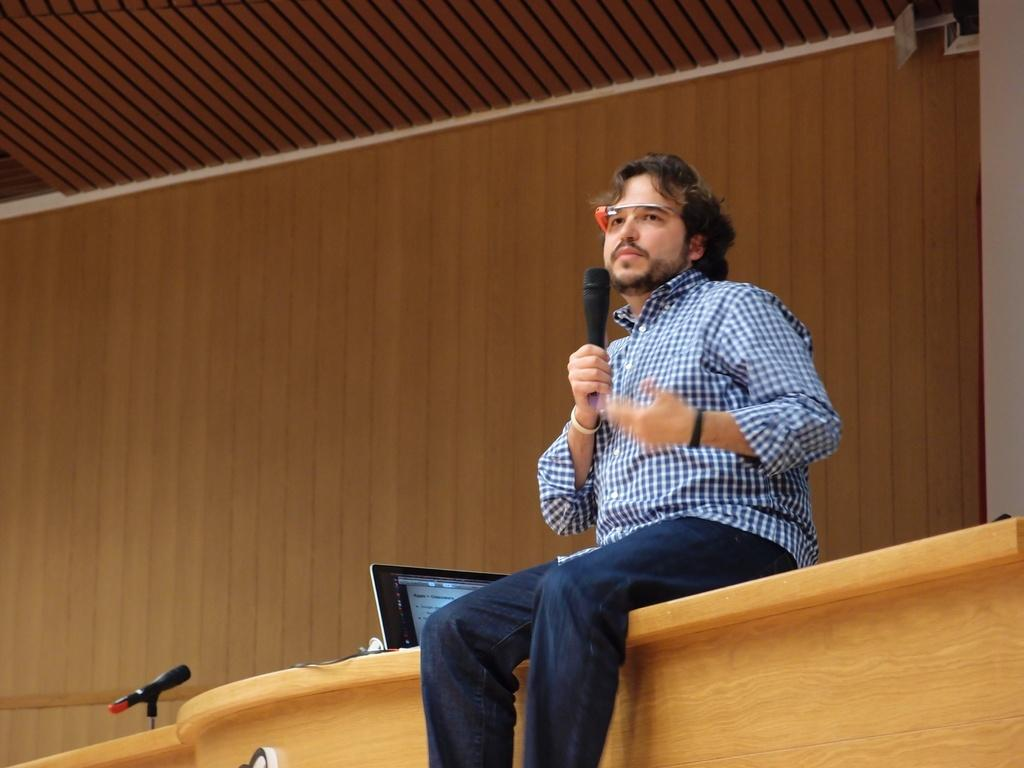Who is present in the image? There is a man in the image. What is the man doing in the image? The man is sitting on a table and holding a mic in his hand. What electronic device can be seen in the image? There is a laptop on a desk in the image. What type of wall is visible in the background of the image? There is a wooden wall in the background of the image. What architectural feature is visible in the background of the image? There is a beautiful roof visible in the background of the image. Where is the drawer located in the image? There is no drawer present in the image. Can you see any steam coming from the laptop in the image? There is no steam visible in the image, and the laptop is not shown to be in use. 